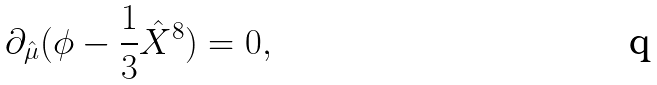<formula> <loc_0><loc_0><loc_500><loc_500>\partial _ { \hat { \mu } } ( \phi - \frac { 1 } { 3 } \hat { X } ^ { 8 } ) = 0 ,</formula> 